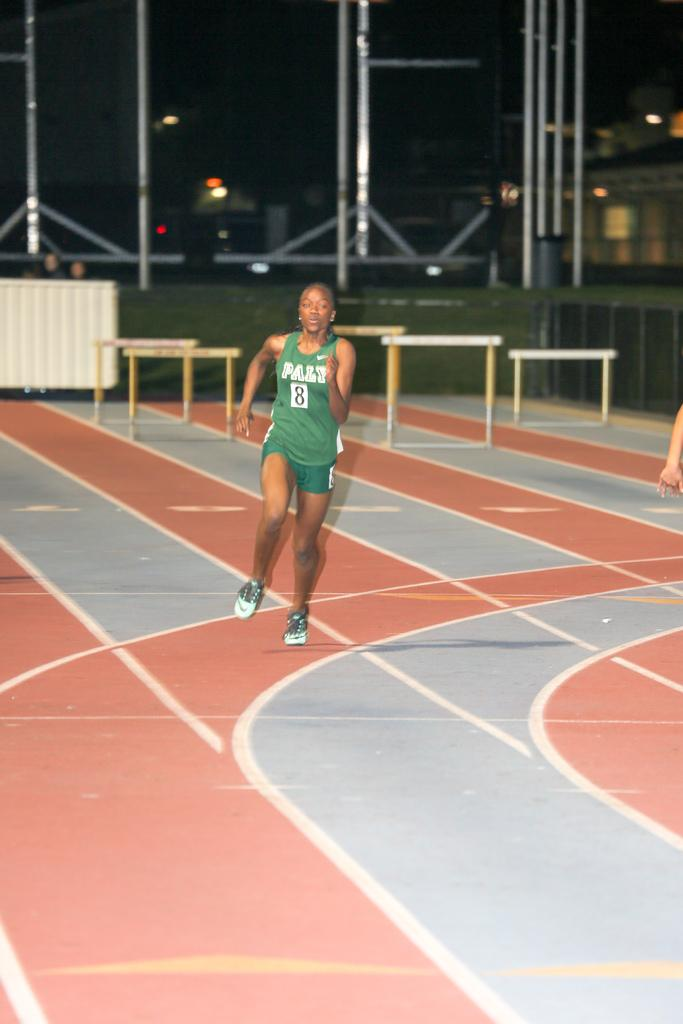What type of person is the main subject in the image? There is an athlete in the image. What can be seen in the background of the image? There are iron grills, walls, the sky, and electric lights visible in the background of the image. What type of fang can be seen in the image? There is no fang present in the image. Where is the meeting taking place in the image? There is no meeting depicted in the image; it features an athlete and background elements. 